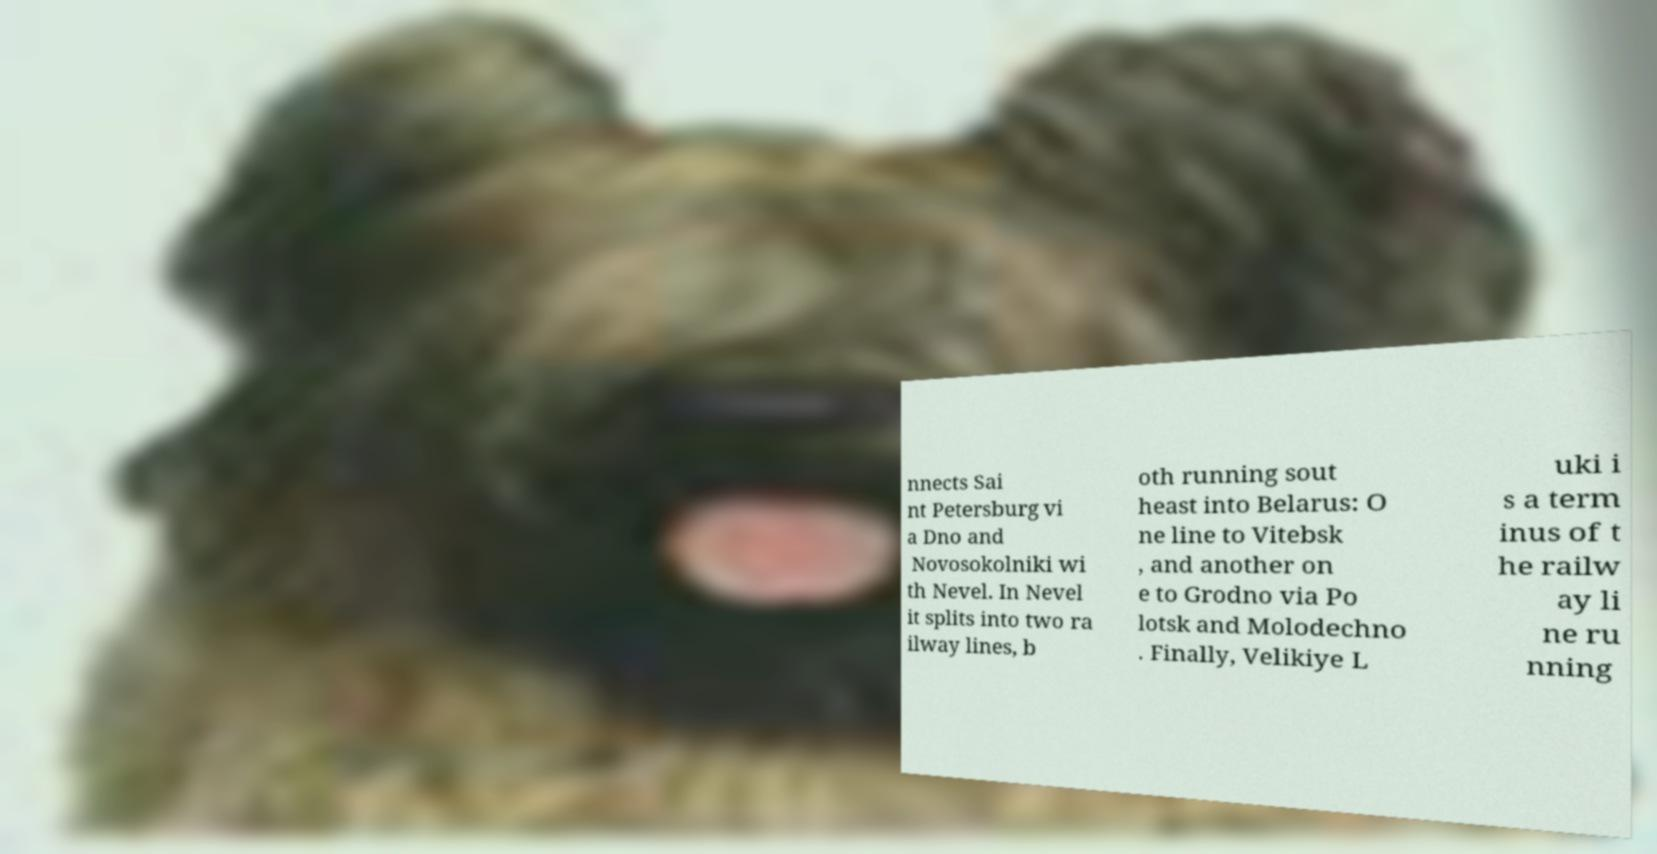Can you accurately transcribe the text from the provided image for me? nnects Sai nt Petersburg vi a Dno and Novosokolniki wi th Nevel. In Nevel it splits into two ra ilway lines, b oth running sout heast into Belarus: O ne line to Vitebsk , and another on e to Grodno via Po lotsk and Molodechno . Finally, Velikiye L uki i s a term inus of t he railw ay li ne ru nning 